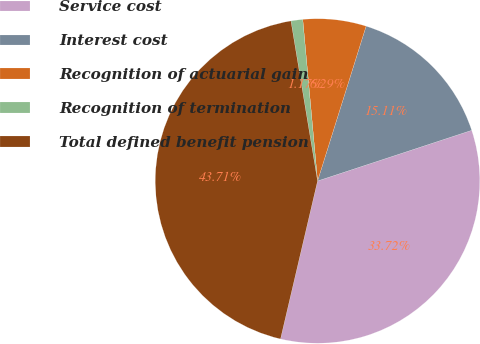<chart> <loc_0><loc_0><loc_500><loc_500><pie_chart><fcel>Service cost<fcel>Interest cost<fcel>Recognition of actuarial gain<fcel>Recognition of termination<fcel>Total defined benefit pension<nl><fcel>33.72%<fcel>15.11%<fcel>6.29%<fcel>1.17%<fcel>43.71%<nl></chart> 